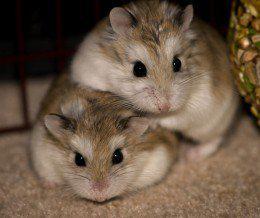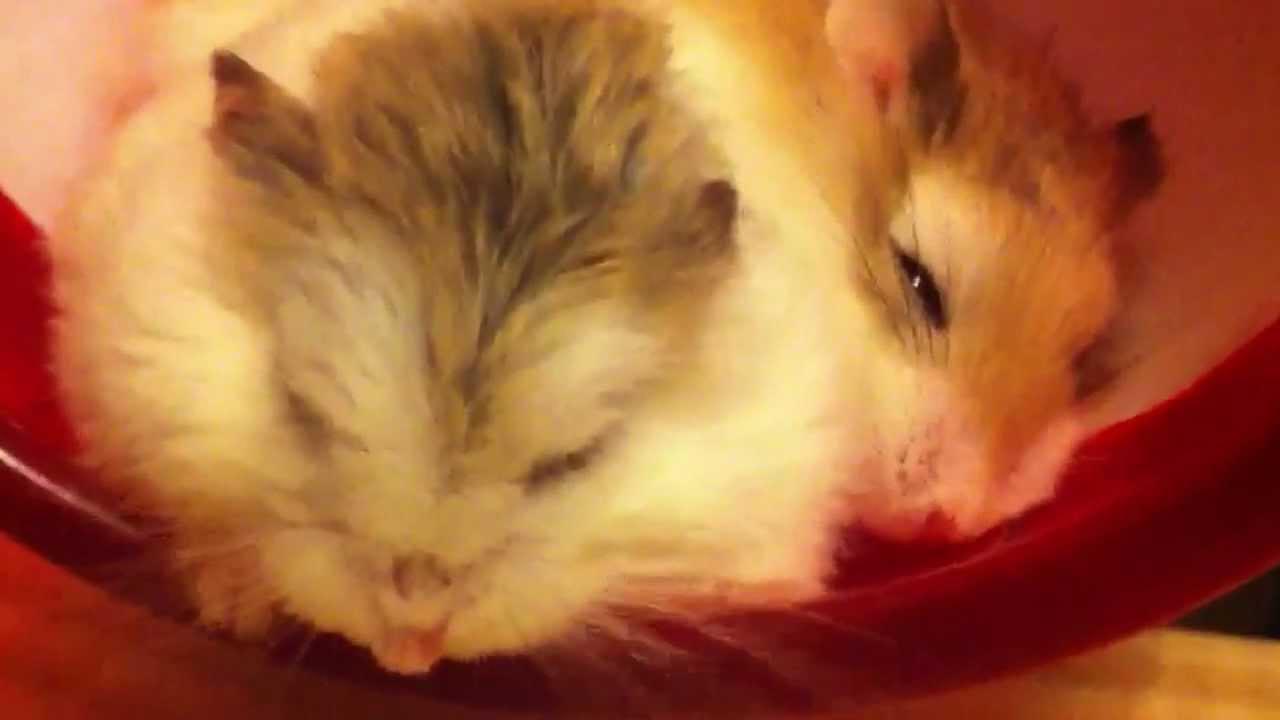The first image is the image on the left, the second image is the image on the right. Analyze the images presented: Is the assertion "In both images, two hamsters are touching each other." valid? Answer yes or no. Yes. The first image is the image on the left, the second image is the image on the right. Considering the images on both sides, is "A human finger is in an image with no more than two hamsters." valid? Answer yes or no. No. 